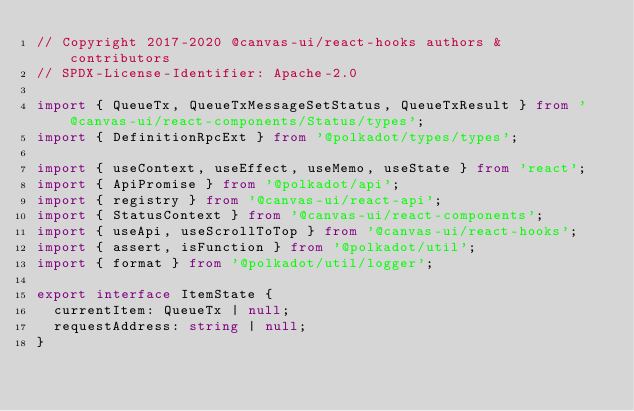<code> <loc_0><loc_0><loc_500><loc_500><_TypeScript_>// Copyright 2017-2020 @canvas-ui/react-hooks authors & contributors
// SPDX-License-Identifier: Apache-2.0

import { QueueTx, QueueTxMessageSetStatus, QueueTxResult } from '@canvas-ui/react-components/Status/types';
import { DefinitionRpcExt } from '@polkadot/types/types';

import { useContext, useEffect, useMemo, useState } from 'react';
import { ApiPromise } from '@polkadot/api';
import { registry } from '@canvas-ui/react-api';
import { StatusContext } from '@canvas-ui/react-components';
import { useApi, useScrollToTop } from '@canvas-ui/react-hooks';
import { assert, isFunction } from '@polkadot/util';
import { format } from '@polkadot/util/logger';

export interface ItemState {
  currentItem: QueueTx | null;
  requestAddress: string | null;
}
</code> 